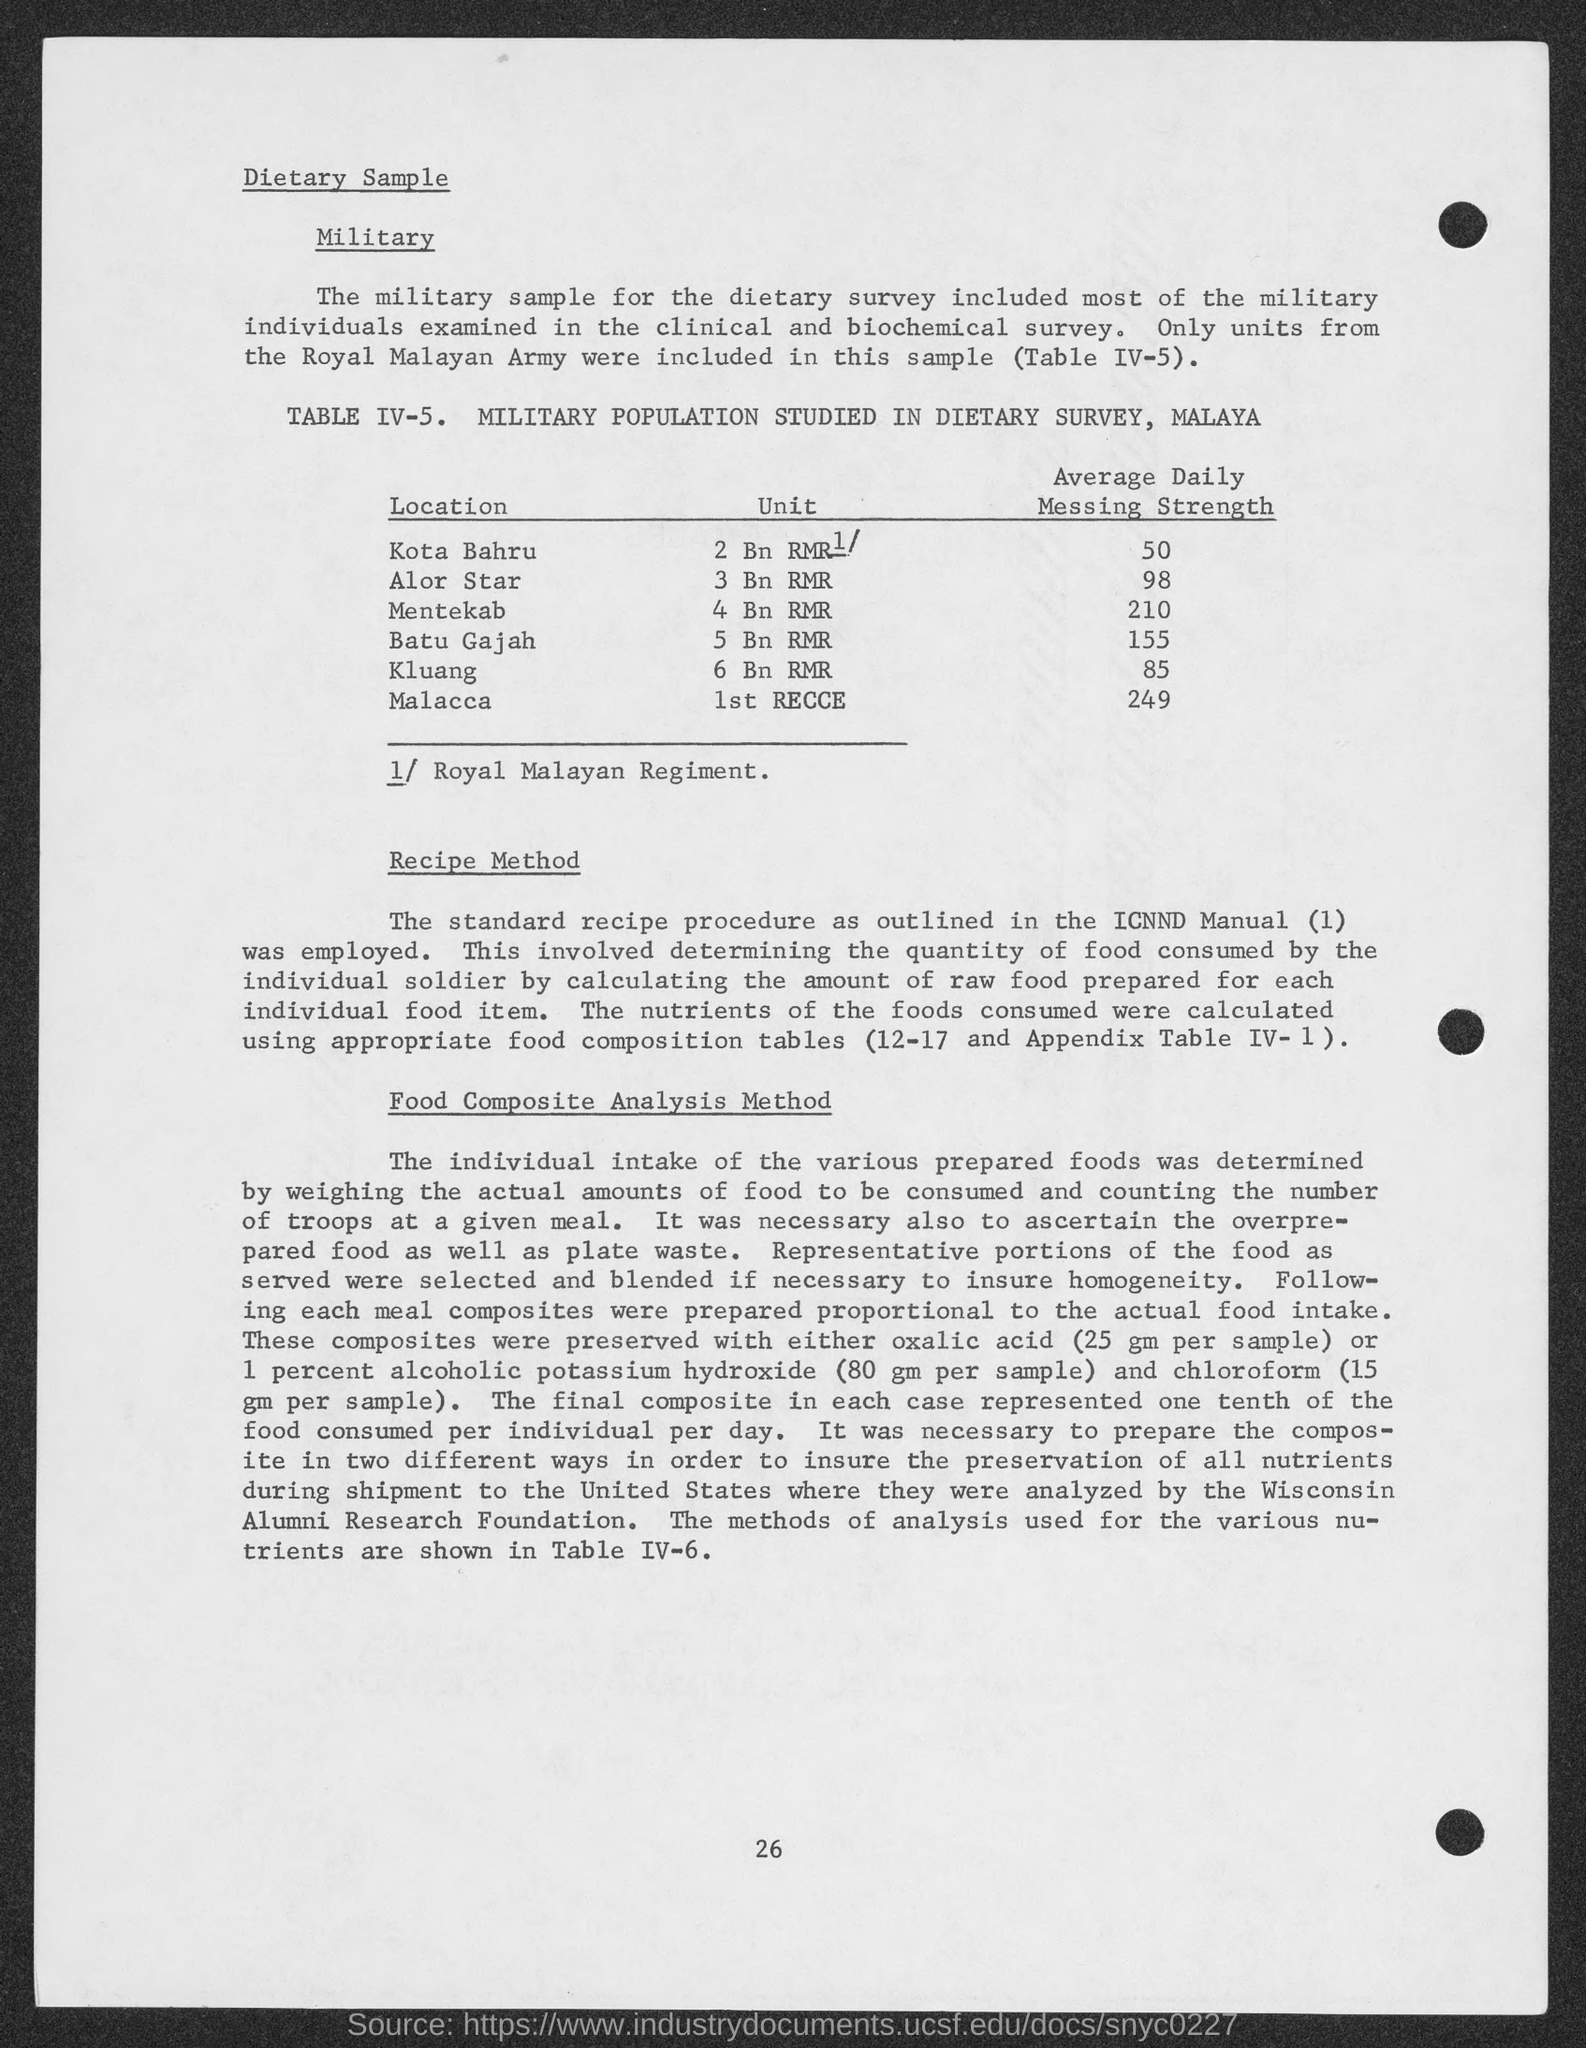What is the Average Daily Messing Strength for Mentekab? The Average Daily Messing Strength for Mentekab, as noted in the dietary survey of the military population, is 210. This figure represents the daily average number of meals prepared for military personnel stationed there. 